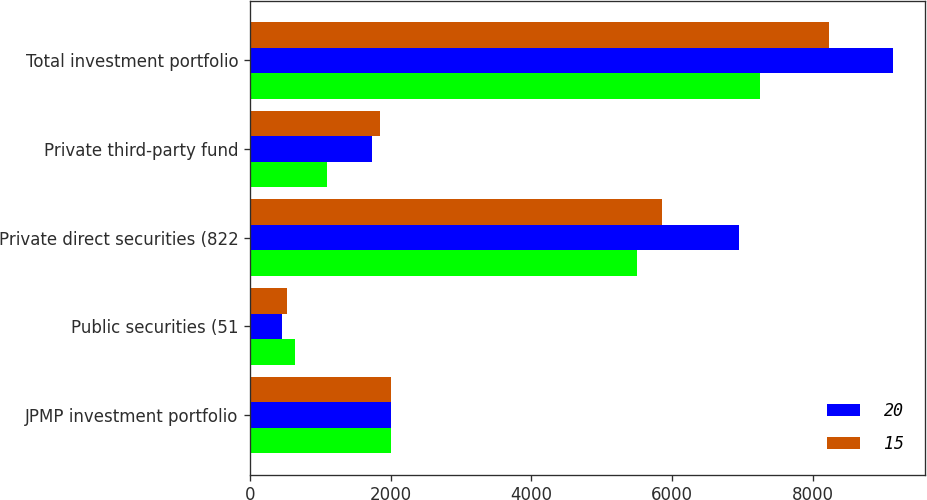<chart> <loc_0><loc_0><loc_500><loc_500><stacked_bar_chart><ecel><fcel>JPMP investment portfolio<fcel>Public securities (51<fcel>Private direct securities (822<fcel>Private third-party fund<fcel>Total investment portfolio<nl><fcel>nan<fcel>2003<fcel>643<fcel>5508<fcel>1099<fcel>7250<nl><fcel>20<fcel>2003<fcel>451<fcel>6960<fcel>1736<fcel>9147<nl><fcel>15<fcel>2002<fcel>520<fcel>5865<fcel>1843<fcel>8228<nl></chart> 